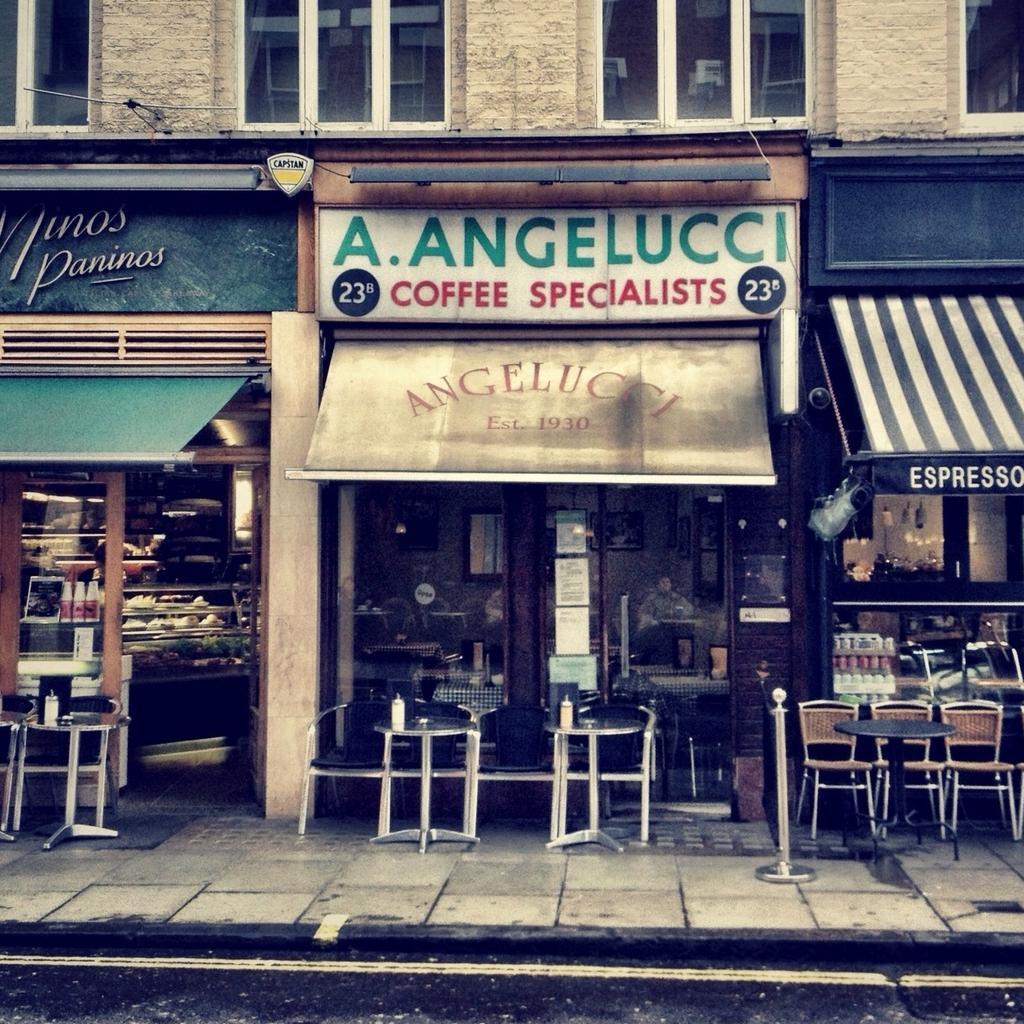Could you give a brief overview of what you see in this image? In this image there are few chairs and tables are on the pavement. Behind it there are few shops. Middle of image few persons are sitting inside the shop. Left side there are few racks having few objects on it. Few name boards are attached to the wall of building having windows. 